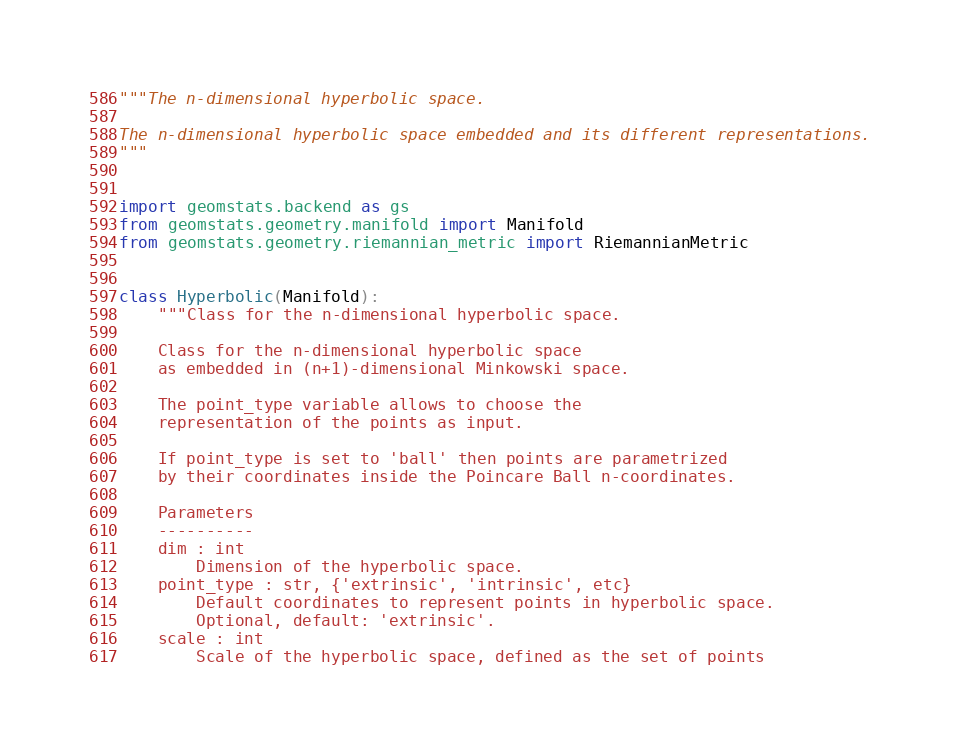<code> <loc_0><loc_0><loc_500><loc_500><_Python_>"""The n-dimensional hyperbolic space.

The n-dimensional hyperbolic space embedded and its different representations.
"""


import geomstats.backend as gs
from geomstats.geometry.manifold import Manifold
from geomstats.geometry.riemannian_metric import RiemannianMetric


class Hyperbolic(Manifold):
    """Class for the n-dimensional hyperbolic space.

    Class for the n-dimensional hyperbolic space
    as embedded in (n+1)-dimensional Minkowski space.

    The point_type variable allows to choose the
    representation of the points as input.

    If point_type is set to 'ball' then points are parametrized
    by their coordinates inside the Poincare Ball n-coordinates.

    Parameters
    ----------
    dim : int
        Dimension of the hyperbolic space.
    point_type : str, {'extrinsic', 'intrinsic', etc}
        Default coordinates to represent points in hyperbolic space.
        Optional, default: 'extrinsic'.
    scale : int
        Scale of the hyperbolic space, defined as the set of points</code> 